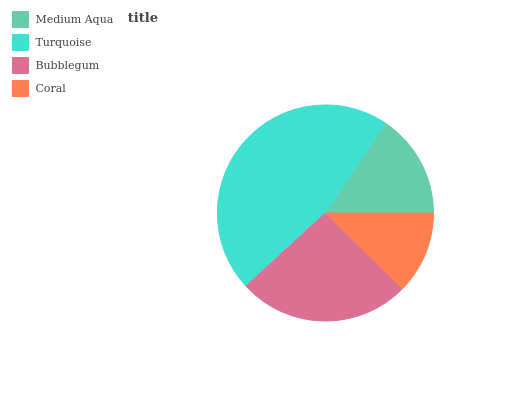Is Coral the minimum?
Answer yes or no. Yes. Is Turquoise the maximum?
Answer yes or no. Yes. Is Bubblegum the minimum?
Answer yes or no. No. Is Bubblegum the maximum?
Answer yes or no. No. Is Turquoise greater than Bubblegum?
Answer yes or no. Yes. Is Bubblegum less than Turquoise?
Answer yes or no. Yes. Is Bubblegum greater than Turquoise?
Answer yes or no. No. Is Turquoise less than Bubblegum?
Answer yes or no. No. Is Bubblegum the high median?
Answer yes or no. Yes. Is Medium Aqua the low median?
Answer yes or no. Yes. Is Turquoise the high median?
Answer yes or no. No. Is Bubblegum the low median?
Answer yes or no. No. 